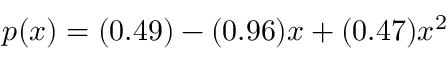<formula> <loc_0><loc_0><loc_500><loc_500>p ( x ) = ( 0 . 4 9 ) - ( 0 . 9 6 ) x + ( 0 . 4 7 ) x ^ { 2 }</formula> 